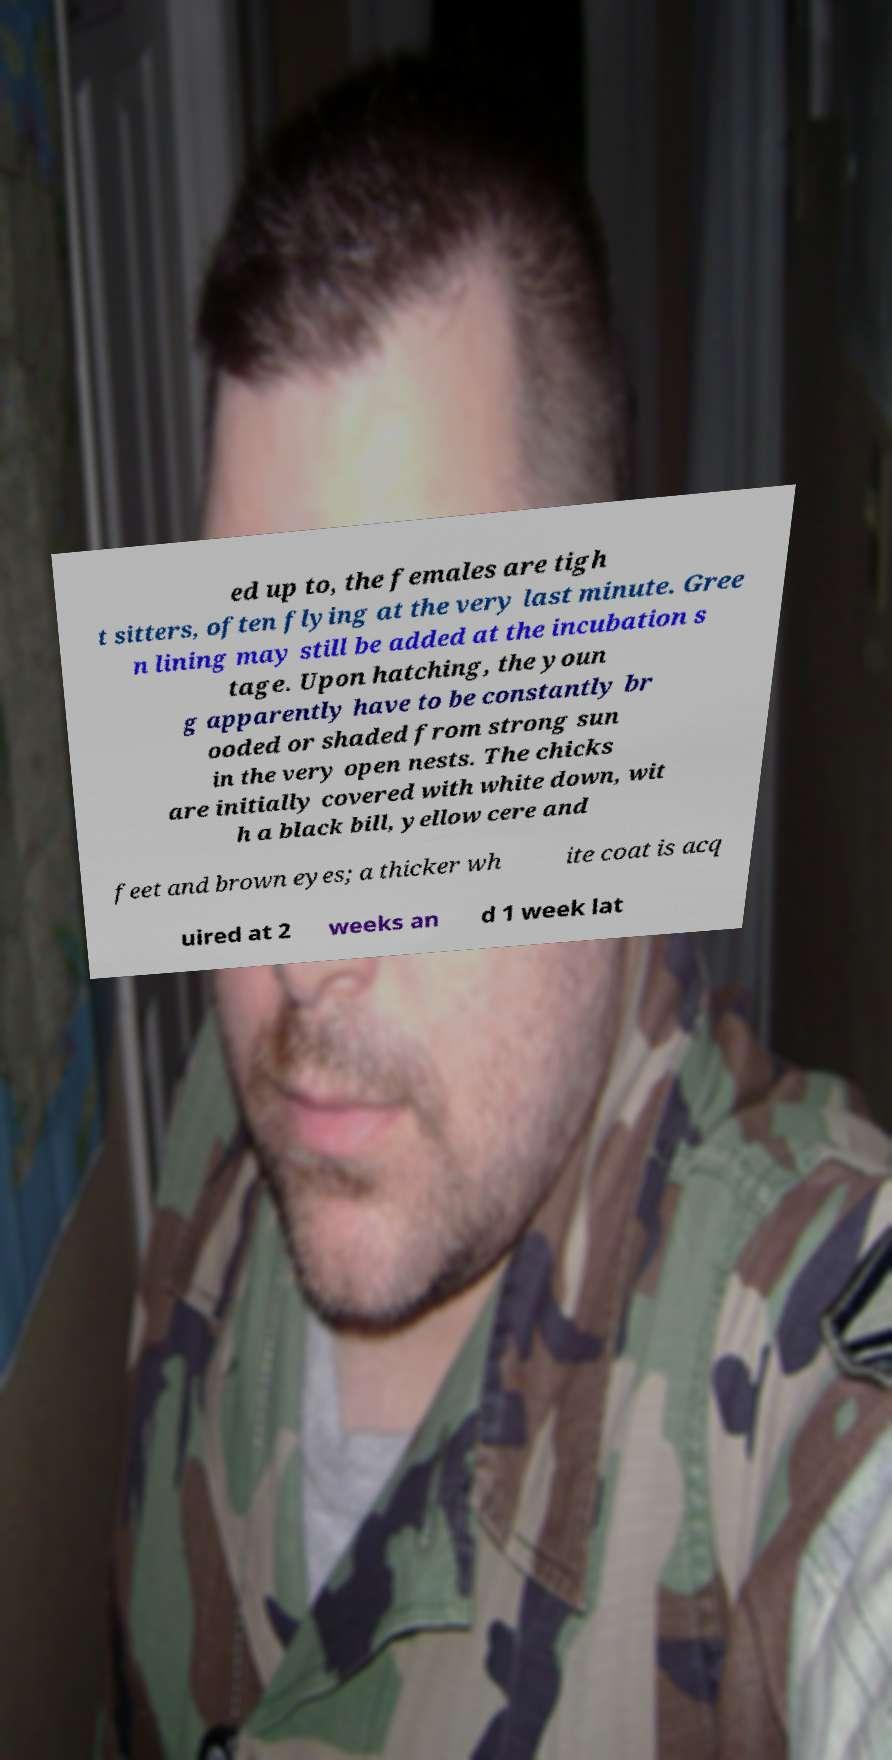For documentation purposes, I need the text within this image transcribed. Could you provide that? ed up to, the females are tigh t sitters, often flying at the very last minute. Gree n lining may still be added at the incubation s tage. Upon hatching, the youn g apparently have to be constantly br ooded or shaded from strong sun in the very open nests. The chicks are initially covered with white down, wit h a black bill, yellow cere and feet and brown eyes; a thicker wh ite coat is acq uired at 2 weeks an d 1 week lat 